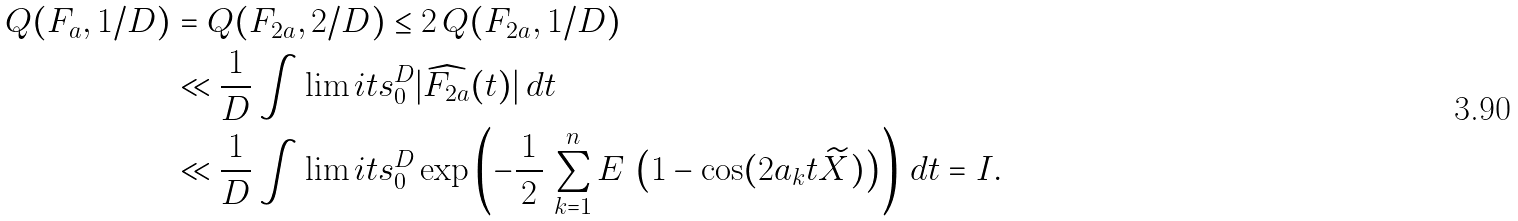Convert formula to latex. <formula><loc_0><loc_0><loc_500><loc_500>Q ( F _ { a } , 1 / D ) & = Q ( F _ { 2 a } , 2 / D ) \leq 2 \, Q ( F _ { 2 a } , 1 / D ) \\ & \ll \frac { 1 } { D } \int \lim i t s _ { 0 } ^ { D } | \widehat { F _ { 2 a } } ( t ) | \, d t \\ & \ll \frac { 1 } { D } \int \lim i t s _ { 0 } ^ { D } \exp \left ( - \frac { \, 1 \, } { 2 } \, \sum _ { k = 1 } ^ { n } E \, \left ( 1 - \cos ( 2 a _ { k } t \widetilde { X } ) \right ) \right ) \, d t = I .</formula> 